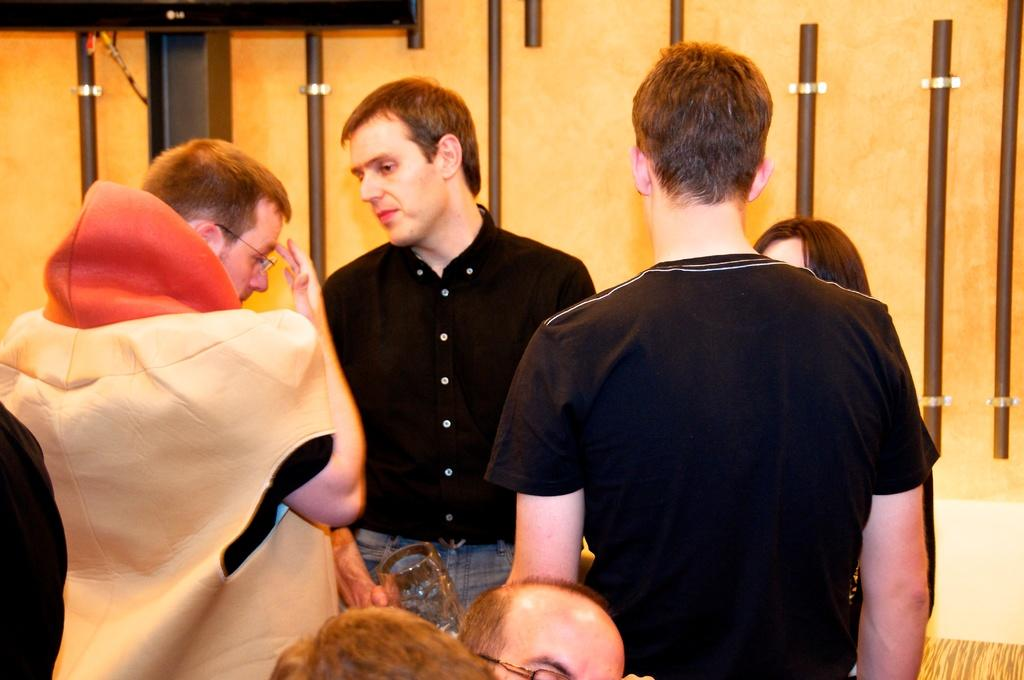How many people are in the image? There are persons in the image, but the exact number cannot be determined from the provided facts. What is located on the wall in the image? There are rods on the wall in the image. Can you describe the black object in the top left of the image? Yes, there is a black object in the top left of the image. What type of tax is being discussed by the persons in the image? There is no indication in the image that the persons are discussing any type of tax. How much jam is on the wall in the image? There is no jam present in the image. 